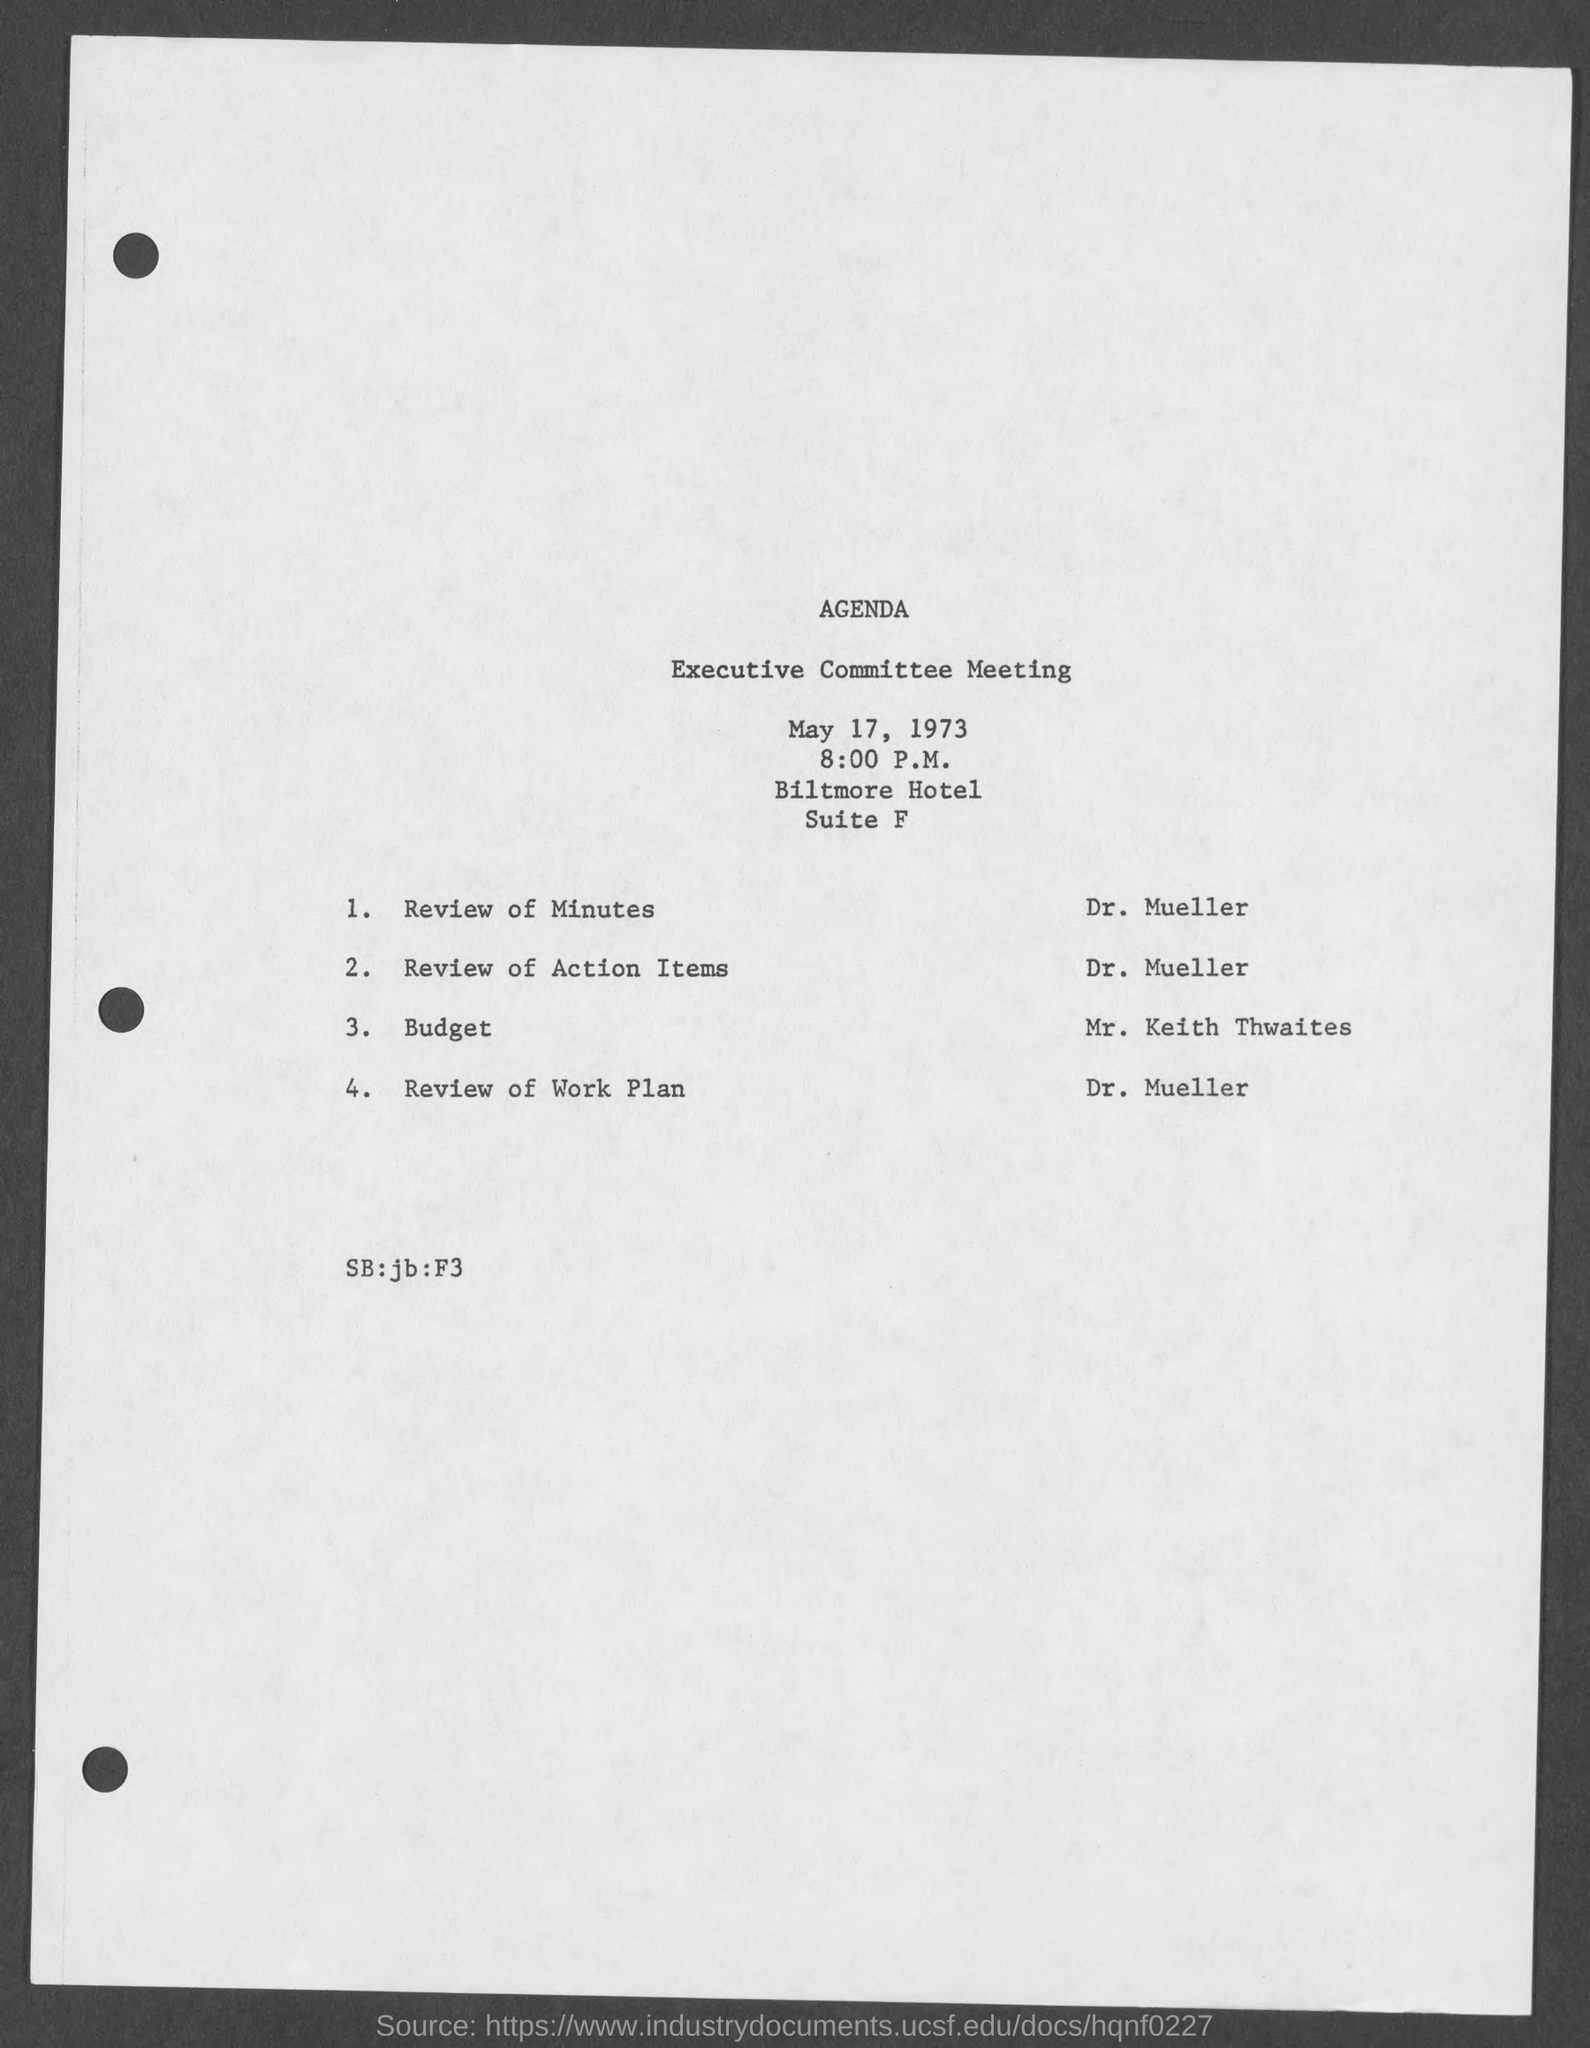What time is the Executive Committee meeting?
Make the answer very short. 8:00 p.m. Who does the Review of Minutes?
Your answer should be very brief. Dr. Mueller. Who does the Review of Action Items?
Your response must be concise. Dr. Mueller. Who does the Budget?
Ensure brevity in your answer.  Mr. Keith thwaites. 